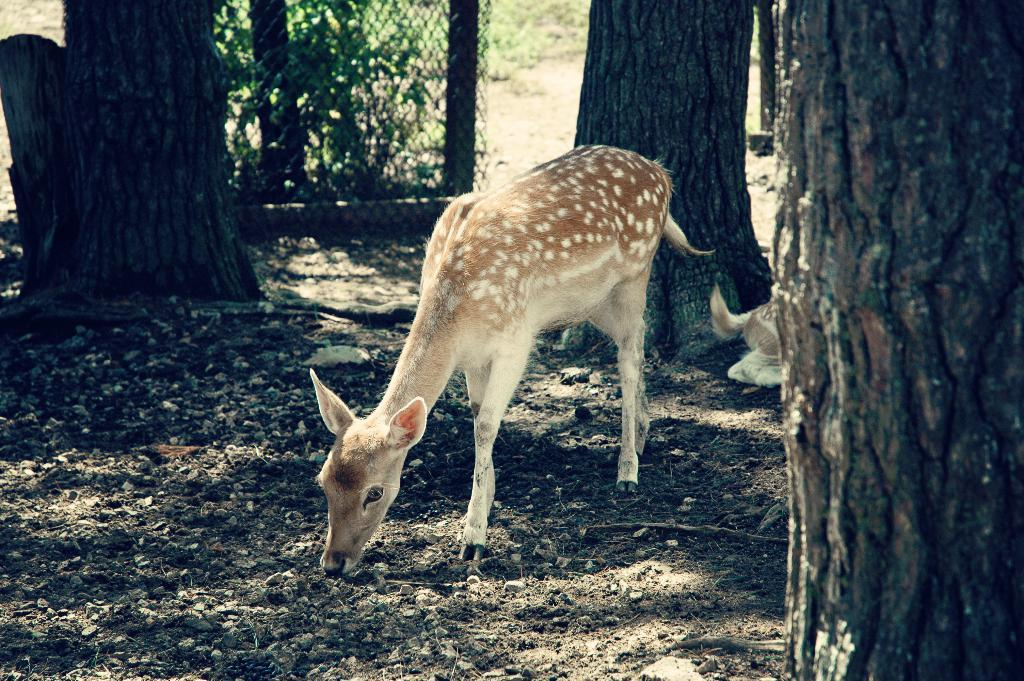How many deers are present in the image? There are two deers in the image. What colors can be seen on the deers? The deers are in brown and cream color. What can be seen in the background of the image? There are trunks, fencing, and plants in green color in the background of the image. What type of plastic material can be seen on the deers' lips in the image? There is no plastic material or any lip-related objects visible on the deers in the image. 